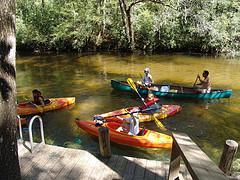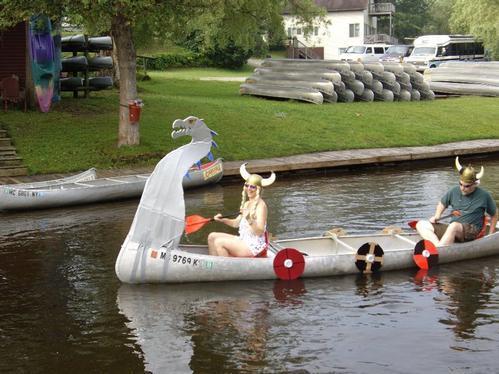The first image is the image on the left, the second image is the image on the right. Assess this claim about the two images: "There is a woman in the image on the right.". Correct or not? Answer yes or no. Yes. 